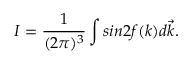<formula> <loc_0><loc_0><loc_500><loc_500>I = \frac { 1 } { ( 2 \pi ) ^ { 3 } } \int \sin 2 f ( k ) d \vec { k } .</formula> 